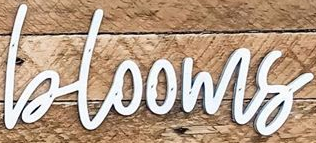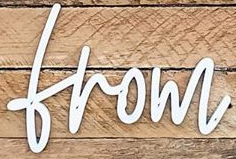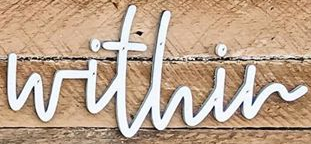What words are shown in these images in order, separated by a semicolon? blooms; from; within 